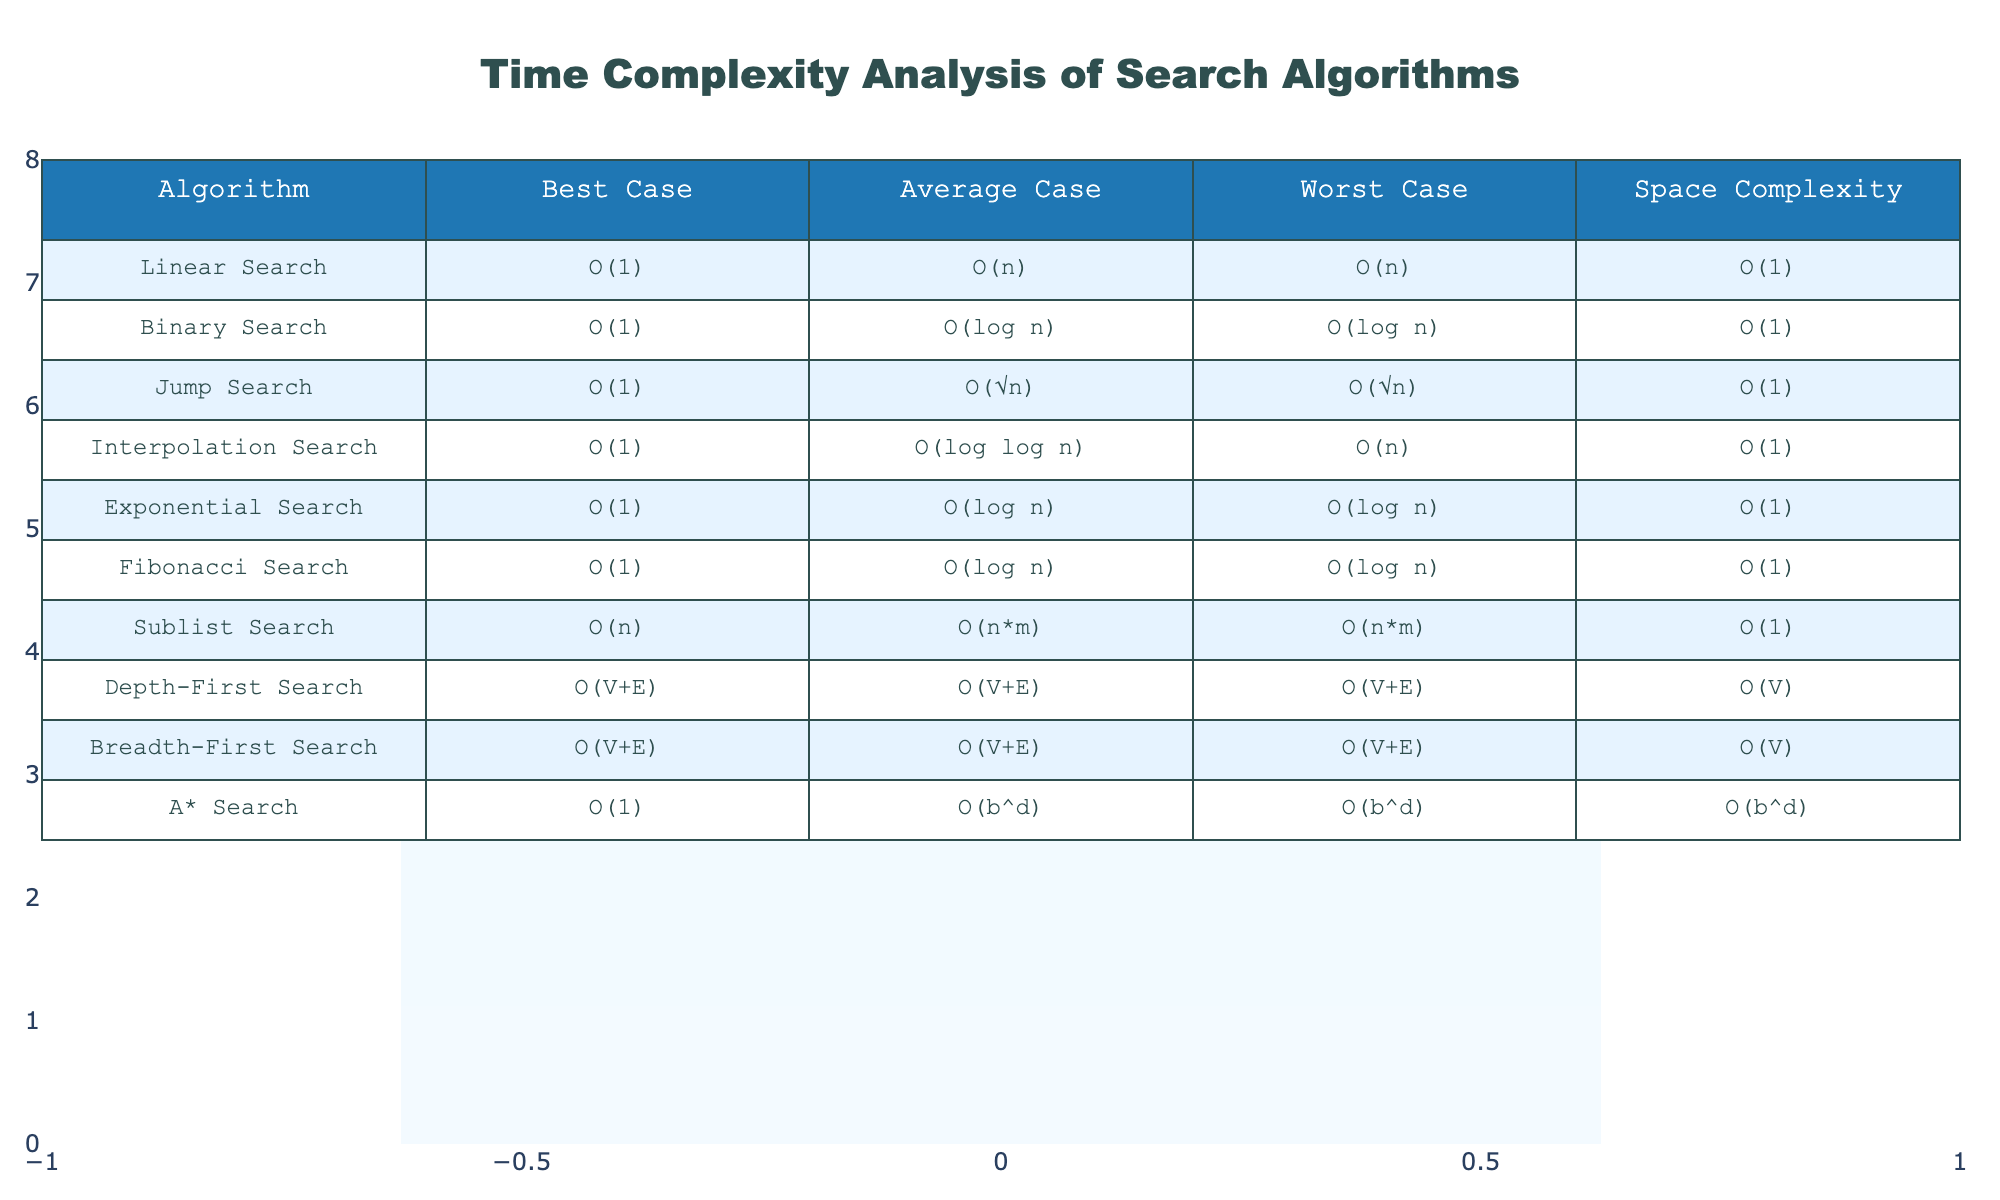What is the space complexity of the Binary Search algorithm? According to the table, the space complexity of the Binary Search algorithm is listed as O(1).
Answer: O(1) Which search algorithm has the worst-case time complexity of O(n)? Looking through the table, the search algorithm with a worst-case time complexity of O(n) is the Interpolation Search, which is confirmed by checking both Average and Worst Case columns.
Answer: Interpolation Search Is the best-case time complexity for all search algorithms O(1)? By inspecting the Best Case column, we see that while many algorithms have a best case of O(1), the Sublist Search has a best case of O(n), indicating that not all have O(1) complexity in the best case.
Answer: No What is the average-case time complexity of the A* Search algorithm? The table lists the average-case time complexity of A* Search as O(b^d).
Answer: O(b^d) Which algorithm has the best average-case time complexity? By evaluating the Average Case column, Jump Search with O(√n) is the best performing algorithm in terms of time complexity in the average case when compared to others.
Answer: Jump Search How many algorithms have a worst-case time complexity of O(log n)? In the Worst Case column, the algorithms that have a worst-case time complexity of O(log n) are Binary Search, Exponential Search, and Fibonacci Search, totaling three algorithms.
Answer: 3 Which algorithms have the same space complexity and what is it? Analyzing the Space Complexity column, we see that all listed algorithms share the same space complexity of O(1), while Depth-First Search and Breadth-First Search have a space complexity of O(V).
Answer: O(1) What is the difference between the average-case complexities of Jump Search and Interpolation Search? From the Average Case column, Jump Search is O(√n) and Interpolation Search is O(log log n). The difference can't be computed precisely since they are not directly comparable mathematically, but qualitatively we can say Jump Search is typically slower for large n.
Answer: Cannot be quantified Which search algorithms would you expect to perform best in scenarios with small datasets? Considering both the time complexities and the results in the table, Linear Search, Binary Search, and Exponential Search all have favorable best-case time complexities implying they can perform efficiently on small datasets.
Answer: Linear, Binary, Exponential 